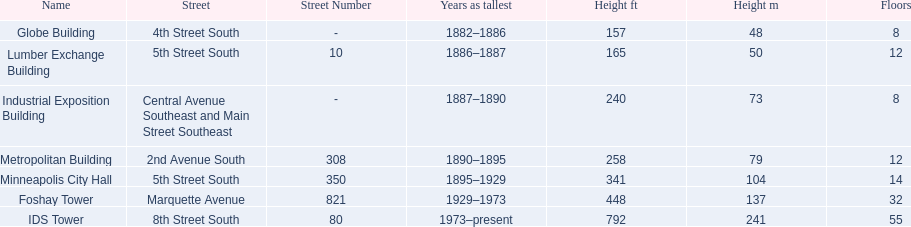What are the tallest buildings in minneapolis? Globe Building, Lumber Exchange Building, Industrial Exposition Building, Metropolitan Building, Minneapolis City Hall, Foshay Tower, IDS Tower. Which of those have 8 floors? Globe Building, Industrial Exposition Building. Of those, which is 240 ft tall? Industrial Exposition Building. 